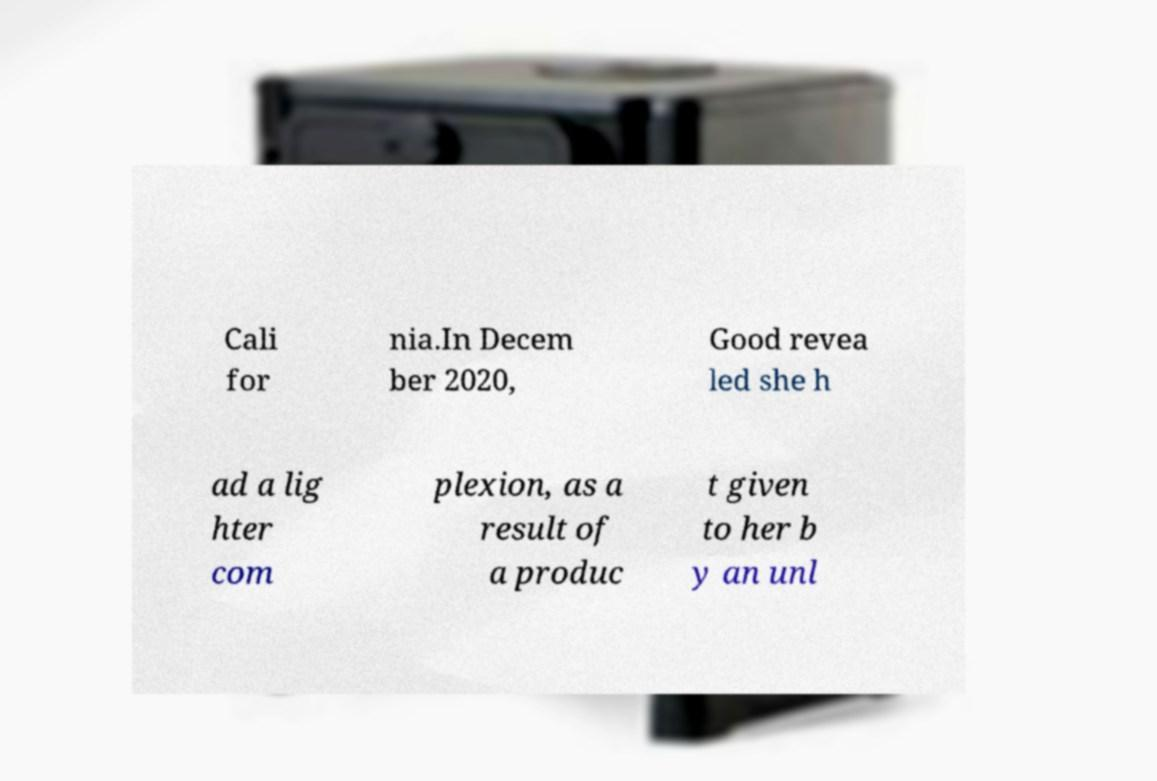I need the written content from this picture converted into text. Can you do that? Cali for nia.In Decem ber 2020, Good revea led she h ad a lig hter com plexion, as a result of a produc t given to her b y an unl 